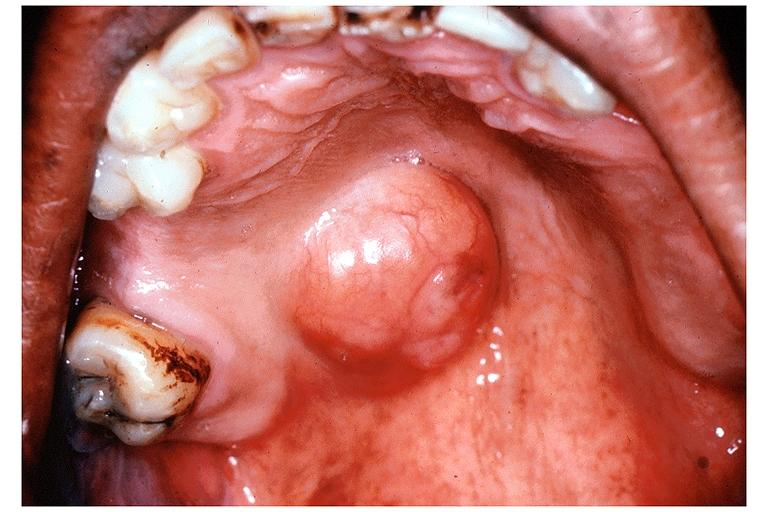does this image show pleomorphic adenoma benign mixed tumor?
Answer the question using a single word or phrase. Yes 